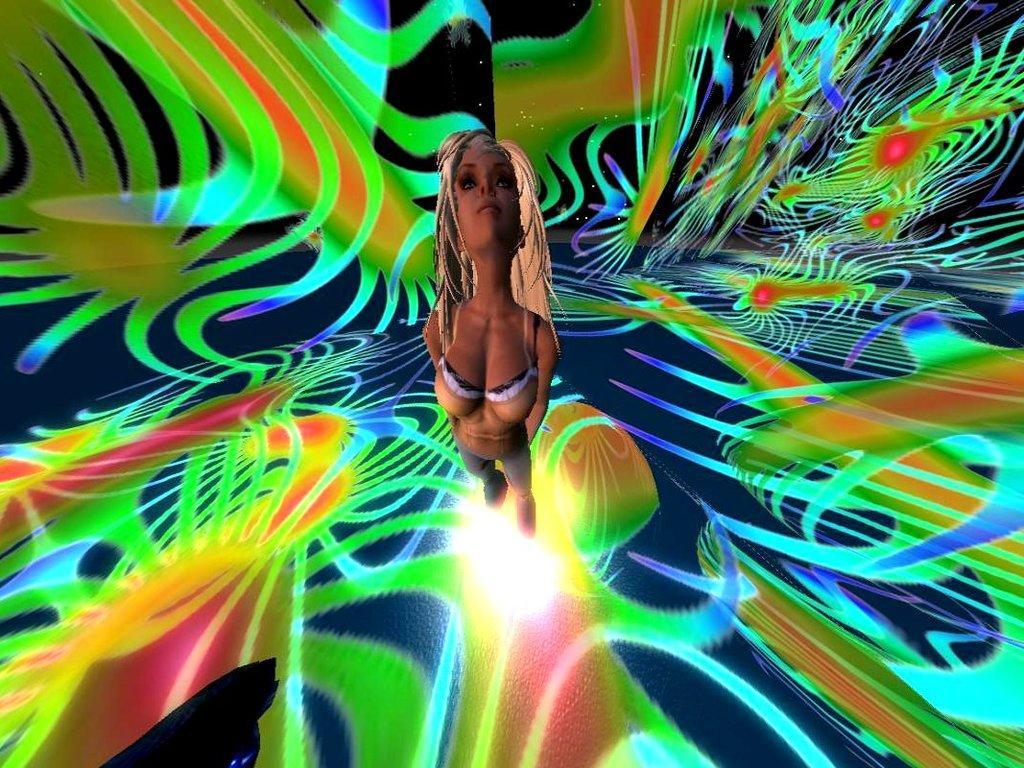In one or two sentences, can you explain what this image depicts? This is animated picture were we can see a girl is standing in the middle of the colorful things and wearing brown color dress. 